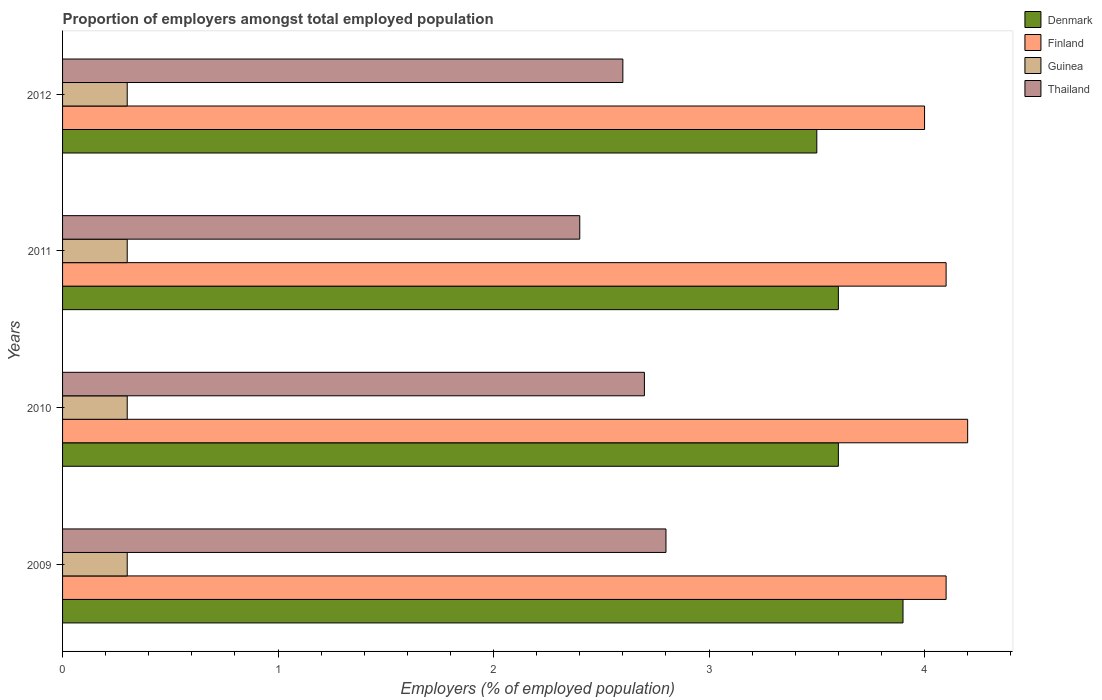How many groups of bars are there?
Make the answer very short. 4. Are the number of bars per tick equal to the number of legend labels?
Offer a very short reply. Yes. How many bars are there on the 2nd tick from the bottom?
Provide a short and direct response. 4. What is the proportion of employers in Thailand in 2010?
Offer a very short reply. 2.7. Across all years, what is the maximum proportion of employers in Guinea?
Offer a very short reply. 0.3. Across all years, what is the minimum proportion of employers in Denmark?
Offer a very short reply. 3.5. In which year was the proportion of employers in Guinea maximum?
Your response must be concise. 2009. In which year was the proportion of employers in Finland minimum?
Offer a very short reply. 2012. What is the total proportion of employers in Denmark in the graph?
Your response must be concise. 14.6. What is the difference between the proportion of employers in Finland in 2010 and the proportion of employers in Guinea in 2012?
Ensure brevity in your answer.  3.9. What is the average proportion of employers in Guinea per year?
Your answer should be very brief. 0.3. In the year 2009, what is the difference between the proportion of employers in Denmark and proportion of employers in Finland?
Keep it short and to the point. -0.2. What is the ratio of the proportion of employers in Finland in 2009 to that in 2012?
Keep it short and to the point. 1.02. Is the proportion of employers in Thailand in 2011 less than that in 2012?
Offer a very short reply. Yes. What is the difference between the highest and the second highest proportion of employers in Finland?
Provide a short and direct response. 0.1. What is the difference between the highest and the lowest proportion of employers in Denmark?
Make the answer very short. 0.4. Is the sum of the proportion of employers in Guinea in 2009 and 2012 greater than the maximum proportion of employers in Denmark across all years?
Give a very brief answer. No. What does the 2nd bar from the top in 2009 represents?
Offer a very short reply. Guinea. What does the 1st bar from the bottom in 2009 represents?
Your response must be concise. Denmark. Is it the case that in every year, the sum of the proportion of employers in Guinea and proportion of employers in Thailand is greater than the proportion of employers in Denmark?
Make the answer very short. No. How many bars are there?
Provide a short and direct response. 16. How many years are there in the graph?
Provide a short and direct response. 4. What is the difference between two consecutive major ticks on the X-axis?
Your answer should be very brief. 1. Where does the legend appear in the graph?
Your answer should be very brief. Top right. How are the legend labels stacked?
Make the answer very short. Vertical. What is the title of the graph?
Keep it short and to the point. Proportion of employers amongst total employed population. What is the label or title of the X-axis?
Offer a very short reply. Employers (% of employed population). What is the Employers (% of employed population) of Denmark in 2009?
Give a very brief answer. 3.9. What is the Employers (% of employed population) in Finland in 2009?
Provide a short and direct response. 4.1. What is the Employers (% of employed population) of Guinea in 2009?
Your answer should be compact. 0.3. What is the Employers (% of employed population) of Thailand in 2009?
Give a very brief answer. 2.8. What is the Employers (% of employed population) of Denmark in 2010?
Offer a very short reply. 3.6. What is the Employers (% of employed population) of Finland in 2010?
Offer a terse response. 4.2. What is the Employers (% of employed population) in Guinea in 2010?
Your answer should be very brief. 0.3. What is the Employers (% of employed population) in Thailand in 2010?
Provide a short and direct response. 2.7. What is the Employers (% of employed population) in Denmark in 2011?
Your response must be concise. 3.6. What is the Employers (% of employed population) in Finland in 2011?
Provide a succinct answer. 4.1. What is the Employers (% of employed population) of Guinea in 2011?
Provide a short and direct response. 0.3. What is the Employers (% of employed population) of Thailand in 2011?
Offer a terse response. 2.4. What is the Employers (% of employed population) in Denmark in 2012?
Provide a short and direct response. 3.5. What is the Employers (% of employed population) in Finland in 2012?
Provide a short and direct response. 4. What is the Employers (% of employed population) of Guinea in 2012?
Your answer should be compact. 0.3. What is the Employers (% of employed population) in Thailand in 2012?
Make the answer very short. 2.6. Across all years, what is the maximum Employers (% of employed population) of Denmark?
Provide a short and direct response. 3.9. Across all years, what is the maximum Employers (% of employed population) in Finland?
Provide a succinct answer. 4.2. Across all years, what is the maximum Employers (% of employed population) in Guinea?
Your response must be concise. 0.3. Across all years, what is the maximum Employers (% of employed population) in Thailand?
Your answer should be compact. 2.8. Across all years, what is the minimum Employers (% of employed population) of Guinea?
Provide a succinct answer. 0.3. Across all years, what is the minimum Employers (% of employed population) of Thailand?
Keep it short and to the point. 2.4. What is the total Employers (% of employed population) in Denmark in the graph?
Your answer should be compact. 14.6. What is the difference between the Employers (% of employed population) in Guinea in 2009 and that in 2010?
Offer a very short reply. 0. What is the difference between the Employers (% of employed population) in Denmark in 2009 and that in 2011?
Provide a succinct answer. 0.3. What is the difference between the Employers (% of employed population) of Guinea in 2009 and that in 2011?
Provide a short and direct response. 0. What is the difference between the Employers (% of employed population) of Denmark in 2009 and that in 2012?
Keep it short and to the point. 0.4. What is the difference between the Employers (% of employed population) in Guinea in 2009 and that in 2012?
Make the answer very short. 0. What is the difference between the Employers (% of employed population) in Thailand in 2009 and that in 2012?
Keep it short and to the point. 0.2. What is the difference between the Employers (% of employed population) of Finland in 2010 and that in 2011?
Ensure brevity in your answer.  0.1. What is the difference between the Employers (% of employed population) of Thailand in 2010 and that in 2011?
Your answer should be compact. 0.3. What is the difference between the Employers (% of employed population) in Denmark in 2010 and that in 2012?
Your response must be concise. 0.1. What is the difference between the Employers (% of employed population) of Finland in 2010 and that in 2012?
Offer a very short reply. 0.2. What is the difference between the Employers (% of employed population) of Guinea in 2011 and that in 2012?
Your answer should be compact. 0. What is the difference between the Employers (% of employed population) of Thailand in 2011 and that in 2012?
Offer a very short reply. -0.2. What is the difference between the Employers (% of employed population) of Denmark in 2009 and the Employers (% of employed population) of Thailand in 2010?
Keep it short and to the point. 1.2. What is the difference between the Employers (% of employed population) in Finland in 2009 and the Employers (% of employed population) in Thailand in 2010?
Provide a succinct answer. 1.4. What is the difference between the Employers (% of employed population) in Denmark in 2009 and the Employers (% of employed population) in Guinea in 2011?
Give a very brief answer. 3.6. What is the difference between the Employers (% of employed population) of Finland in 2009 and the Employers (% of employed population) of Guinea in 2011?
Offer a very short reply. 3.8. What is the difference between the Employers (% of employed population) in Denmark in 2009 and the Employers (% of employed population) in Thailand in 2012?
Your answer should be very brief. 1.3. What is the difference between the Employers (% of employed population) of Finland in 2009 and the Employers (% of employed population) of Guinea in 2012?
Offer a very short reply. 3.8. What is the difference between the Employers (% of employed population) of Guinea in 2009 and the Employers (% of employed population) of Thailand in 2012?
Your answer should be compact. -2.3. What is the difference between the Employers (% of employed population) of Denmark in 2010 and the Employers (% of employed population) of Thailand in 2011?
Give a very brief answer. 1.2. What is the difference between the Employers (% of employed population) in Finland in 2010 and the Employers (% of employed population) in Guinea in 2011?
Provide a succinct answer. 3.9. What is the difference between the Employers (% of employed population) in Guinea in 2010 and the Employers (% of employed population) in Thailand in 2011?
Provide a succinct answer. -2.1. What is the difference between the Employers (% of employed population) in Finland in 2010 and the Employers (% of employed population) in Guinea in 2012?
Provide a succinct answer. 3.9. What is the difference between the Employers (% of employed population) in Guinea in 2010 and the Employers (% of employed population) in Thailand in 2012?
Provide a short and direct response. -2.3. What is the difference between the Employers (% of employed population) in Denmark in 2011 and the Employers (% of employed population) in Finland in 2012?
Keep it short and to the point. -0.4. What is the difference between the Employers (% of employed population) of Denmark in 2011 and the Employers (% of employed population) of Guinea in 2012?
Your answer should be very brief. 3.3. What is the difference between the Employers (% of employed population) of Finland in 2011 and the Employers (% of employed population) of Guinea in 2012?
Give a very brief answer. 3.8. What is the difference between the Employers (% of employed population) of Guinea in 2011 and the Employers (% of employed population) of Thailand in 2012?
Your response must be concise. -2.3. What is the average Employers (% of employed population) in Denmark per year?
Provide a succinct answer. 3.65. What is the average Employers (% of employed population) in Finland per year?
Offer a terse response. 4.1. What is the average Employers (% of employed population) in Guinea per year?
Your response must be concise. 0.3. What is the average Employers (% of employed population) in Thailand per year?
Provide a short and direct response. 2.62. In the year 2009, what is the difference between the Employers (% of employed population) in Denmark and Employers (% of employed population) in Finland?
Provide a succinct answer. -0.2. In the year 2009, what is the difference between the Employers (% of employed population) in Denmark and Employers (% of employed population) in Guinea?
Give a very brief answer. 3.6. In the year 2009, what is the difference between the Employers (% of employed population) of Finland and Employers (% of employed population) of Thailand?
Ensure brevity in your answer.  1.3. In the year 2010, what is the difference between the Employers (% of employed population) of Denmark and Employers (% of employed population) of Guinea?
Your answer should be very brief. 3.3. In the year 2010, what is the difference between the Employers (% of employed population) of Denmark and Employers (% of employed population) of Thailand?
Offer a terse response. 0.9. In the year 2010, what is the difference between the Employers (% of employed population) in Finland and Employers (% of employed population) in Guinea?
Your answer should be very brief. 3.9. In the year 2010, what is the difference between the Employers (% of employed population) in Finland and Employers (% of employed population) in Thailand?
Your response must be concise. 1.5. In the year 2011, what is the difference between the Employers (% of employed population) in Denmark and Employers (% of employed population) in Finland?
Give a very brief answer. -0.5. In the year 2011, what is the difference between the Employers (% of employed population) in Denmark and Employers (% of employed population) in Thailand?
Offer a terse response. 1.2. In the year 2011, what is the difference between the Employers (% of employed population) in Finland and Employers (% of employed population) in Thailand?
Provide a succinct answer. 1.7. In the year 2011, what is the difference between the Employers (% of employed population) in Guinea and Employers (% of employed population) in Thailand?
Provide a succinct answer. -2.1. In the year 2012, what is the difference between the Employers (% of employed population) in Denmark and Employers (% of employed population) in Finland?
Make the answer very short. -0.5. In the year 2012, what is the difference between the Employers (% of employed population) of Denmark and Employers (% of employed population) of Thailand?
Keep it short and to the point. 0.9. In the year 2012, what is the difference between the Employers (% of employed population) of Guinea and Employers (% of employed population) of Thailand?
Give a very brief answer. -2.3. What is the ratio of the Employers (% of employed population) of Denmark in 2009 to that in 2010?
Offer a very short reply. 1.08. What is the ratio of the Employers (% of employed population) in Finland in 2009 to that in 2010?
Provide a short and direct response. 0.98. What is the ratio of the Employers (% of employed population) in Thailand in 2009 to that in 2010?
Keep it short and to the point. 1.04. What is the ratio of the Employers (% of employed population) of Finland in 2009 to that in 2011?
Offer a very short reply. 1. What is the ratio of the Employers (% of employed population) of Guinea in 2009 to that in 2011?
Your answer should be very brief. 1. What is the ratio of the Employers (% of employed population) of Denmark in 2009 to that in 2012?
Your answer should be compact. 1.11. What is the ratio of the Employers (% of employed population) of Finland in 2009 to that in 2012?
Provide a succinct answer. 1.02. What is the ratio of the Employers (% of employed population) of Guinea in 2009 to that in 2012?
Provide a succinct answer. 1. What is the ratio of the Employers (% of employed population) of Thailand in 2009 to that in 2012?
Make the answer very short. 1.08. What is the ratio of the Employers (% of employed population) of Finland in 2010 to that in 2011?
Your response must be concise. 1.02. What is the ratio of the Employers (% of employed population) in Thailand in 2010 to that in 2011?
Your answer should be compact. 1.12. What is the ratio of the Employers (% of employed population) in Denmark in 2010 to that in 2012?
Provide a succinct answer. 1.03. What is the ratio of the Employers (% of employed population) of Finland in 2010 to that in 2012?
Your answer should be very brief. 1.05. What is the ratio of the Employers (% of employed population) of Thailand in 2010 to that in 2012?
Provide a short and direct response. 1.04. What is the ratio of the Employers (% of employed population) in Denmark in 2011 to that in 2012?
Provide a succinct answer. 1.03. What is the ratio of the Employers (% of employed population) of Finland in 2011 to that in 2012?
Make the answer very short. 1.02. What is the ratio of the Employers (% of employed population) in Guinea in 2011 to that in 2012?
Ensure brevity in your answer.  1. What is the ratio of the Employers (% of employed population) in Thailand in 2011 to that in 2012?
Ensure brevity in your answer.  0.92. What is the difference between the highest and the second highest Employers (% of employed population) of Guinea?
Keep it short and to the point. 0. 